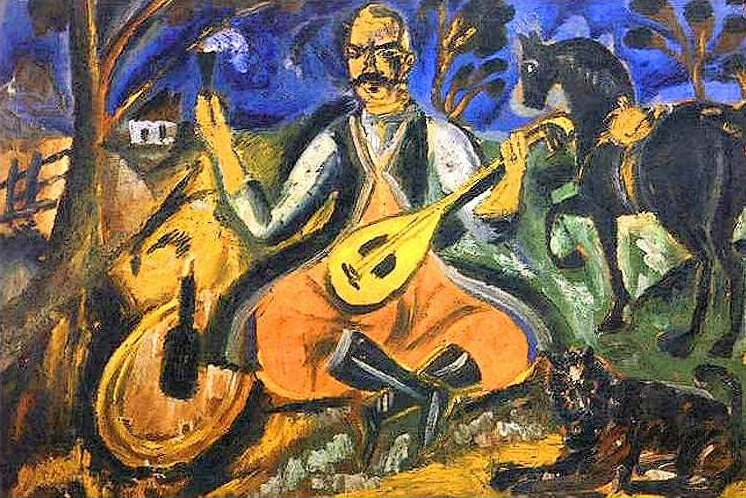What emotions does the man playing the lute seem to convey? The man appears to convey a deep sense of introspection and serenity. His focused expression and the gentle handling of the lute suggest a moment of peace and personal enjoyment, possibly providing an escape through his music from the everyday worries. 